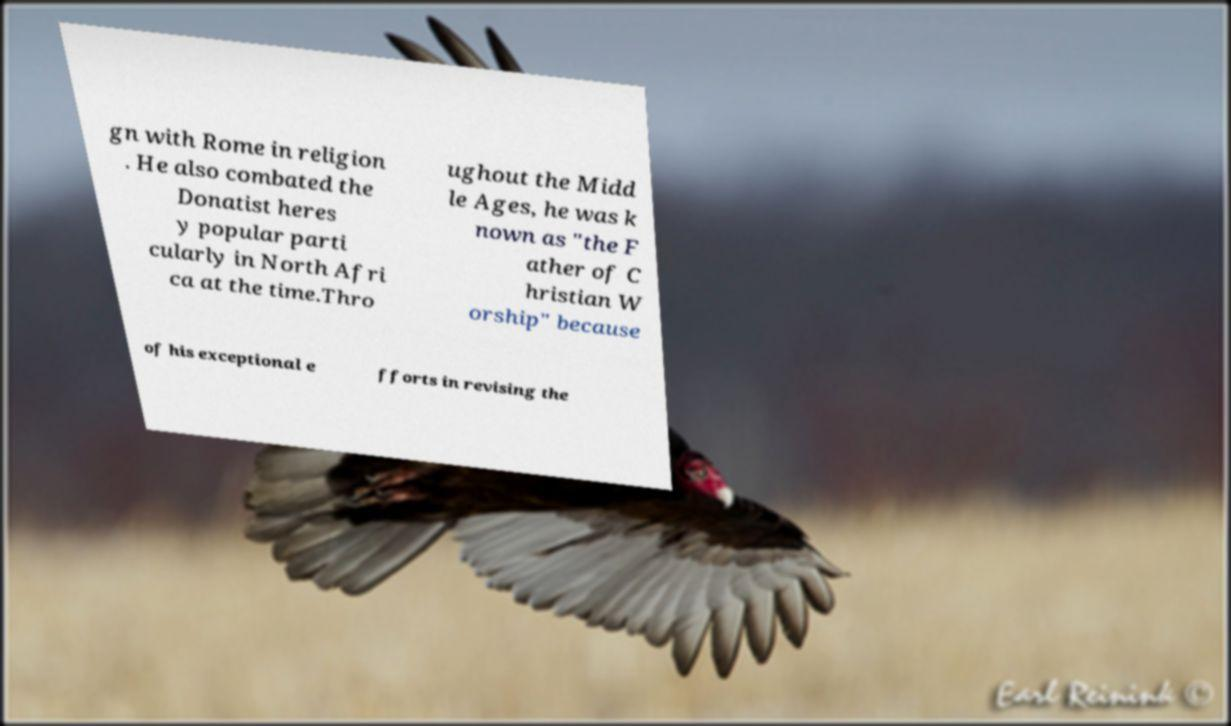Can you accurately transcribe the text from the provided image for me? gn with Rome in religion . He also combated the Donatist heres y popular parti cularly in North Afri ca at the time.Thro ughout the Midd le Ages, he was k nown as "the F ather of C hristian W orship" because of his exceptional e fforts in revising the 